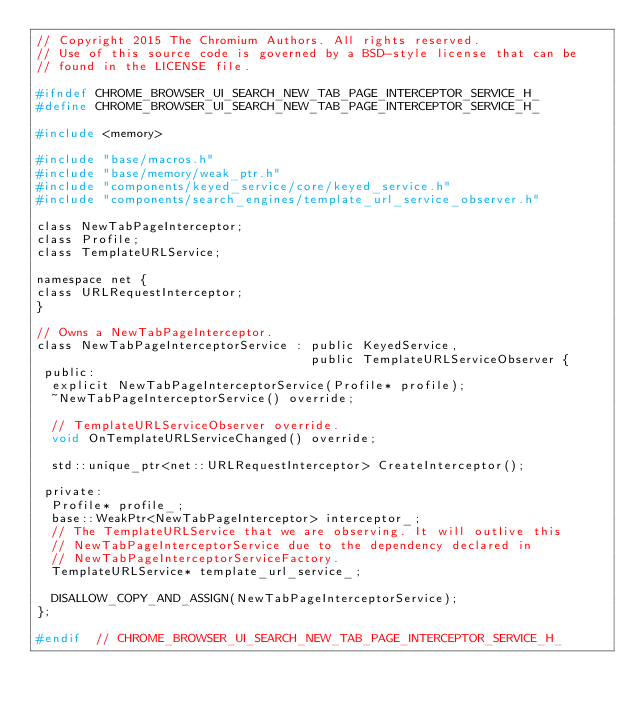Convert code to text. <code><loc_0><loc_0><loc_500><loc_500><_C_>// Copyright 2015 The Chromium Authors. All rights reserved.
// Use of this source code is governed by a BSD-style license that can be
// found in the LICENSE file.

#ifndef CHROME_BROWSER_UI_SEARCH_NEW_TAB_PAGE_INTERCEPTOR_SERVICE_H_
#define CHROME_BROWSER_UI_SEARCH_NEW_TAB_PAGE_INTERCEPTOR_SERVICE_H_

#include <memory>

#include "base/macros.h"
#include "base/memory/weak_ptr.h"
#include "components/keyed_service/core/keyed_service.h"
#include "components/search_engines/template_url_service_observer.h"

class NewTabPageInterceptor;
class Profile;
class TemplateURLService;

namespace net {
class URLRequestInterceptor;
}

// Owns a NewTabPageInterceptor.
class NewTabPageInterceptorService : public KeyedService,
                                     public TemplateURLServiceObserver {
 public:
  explicit NewTabPageInterceptorService(Profile* profile);
  ~NewTabPageInterceptorService() override;

  // TemplateURLServiceObserver override.
  void OnTemplateURLServiceChanged() override;

  std::unique_ptr<net::URLRequestInterceptor> CreateInterceptor();

 private:
  Profile* profile_;
  base::WeakPtr<NewTabPageInterceptor> interceptor_;
  // The TemplateURLService that we are observing. It will outlive this
  // NewTabPageInterceptorService due to the dependency declared in
  // NewTabPageInterceptorServiceFactory.
  TemplateURLService* template_url_service_;

  DISALLOW_COPY_AND_ASSIGN(NewTabPageInterceptorService);
};

#endif  // CHROME_BROWSER_UI_SEARCH_NEW_TAB_PAGE_INTERCEPTOR_SERVICE_H_
</code> 